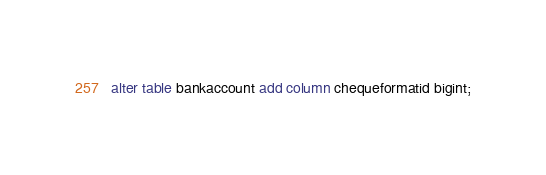Convert code to text. <code><loc_0><loc_0><loc_500><loc_500><_SQL_>alter table bankaccount add column chequeformatid bigint;</code> 